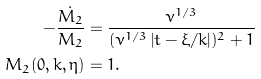Convert formula to latex. <formula><loc_0><loc_0><loc_500><loc_500>- \frac { \dot { M _ { 2 } } } { M _ { 2 } } & = \frac { \nu ^ { 1 / 3 } } { ( \nu ^ { 1 / 3 } \left | t - \xi / k \right | ) ^ { 2 } + 1 } \\ M _ { 2 } ( 0 , k , \eta ) & = 1 .</formula> 